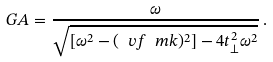<formula> <loc_0><loc_0><loc_500><loc_500>\ G A = \frac { \omega } { \sqrt { [ \omega ^ { 2 } - ( \ v f \ m k ) ^ { 2 } ] - 4 t _ { \perp } ^ { 2 } \omega ^ { 2 } } } \, .</formula> 